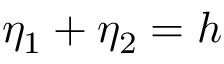<formula> <loc_0><loc_0><loc_500><loc_500>\eta _ { 1 } + \eta _ { 2 } = h</formula> 